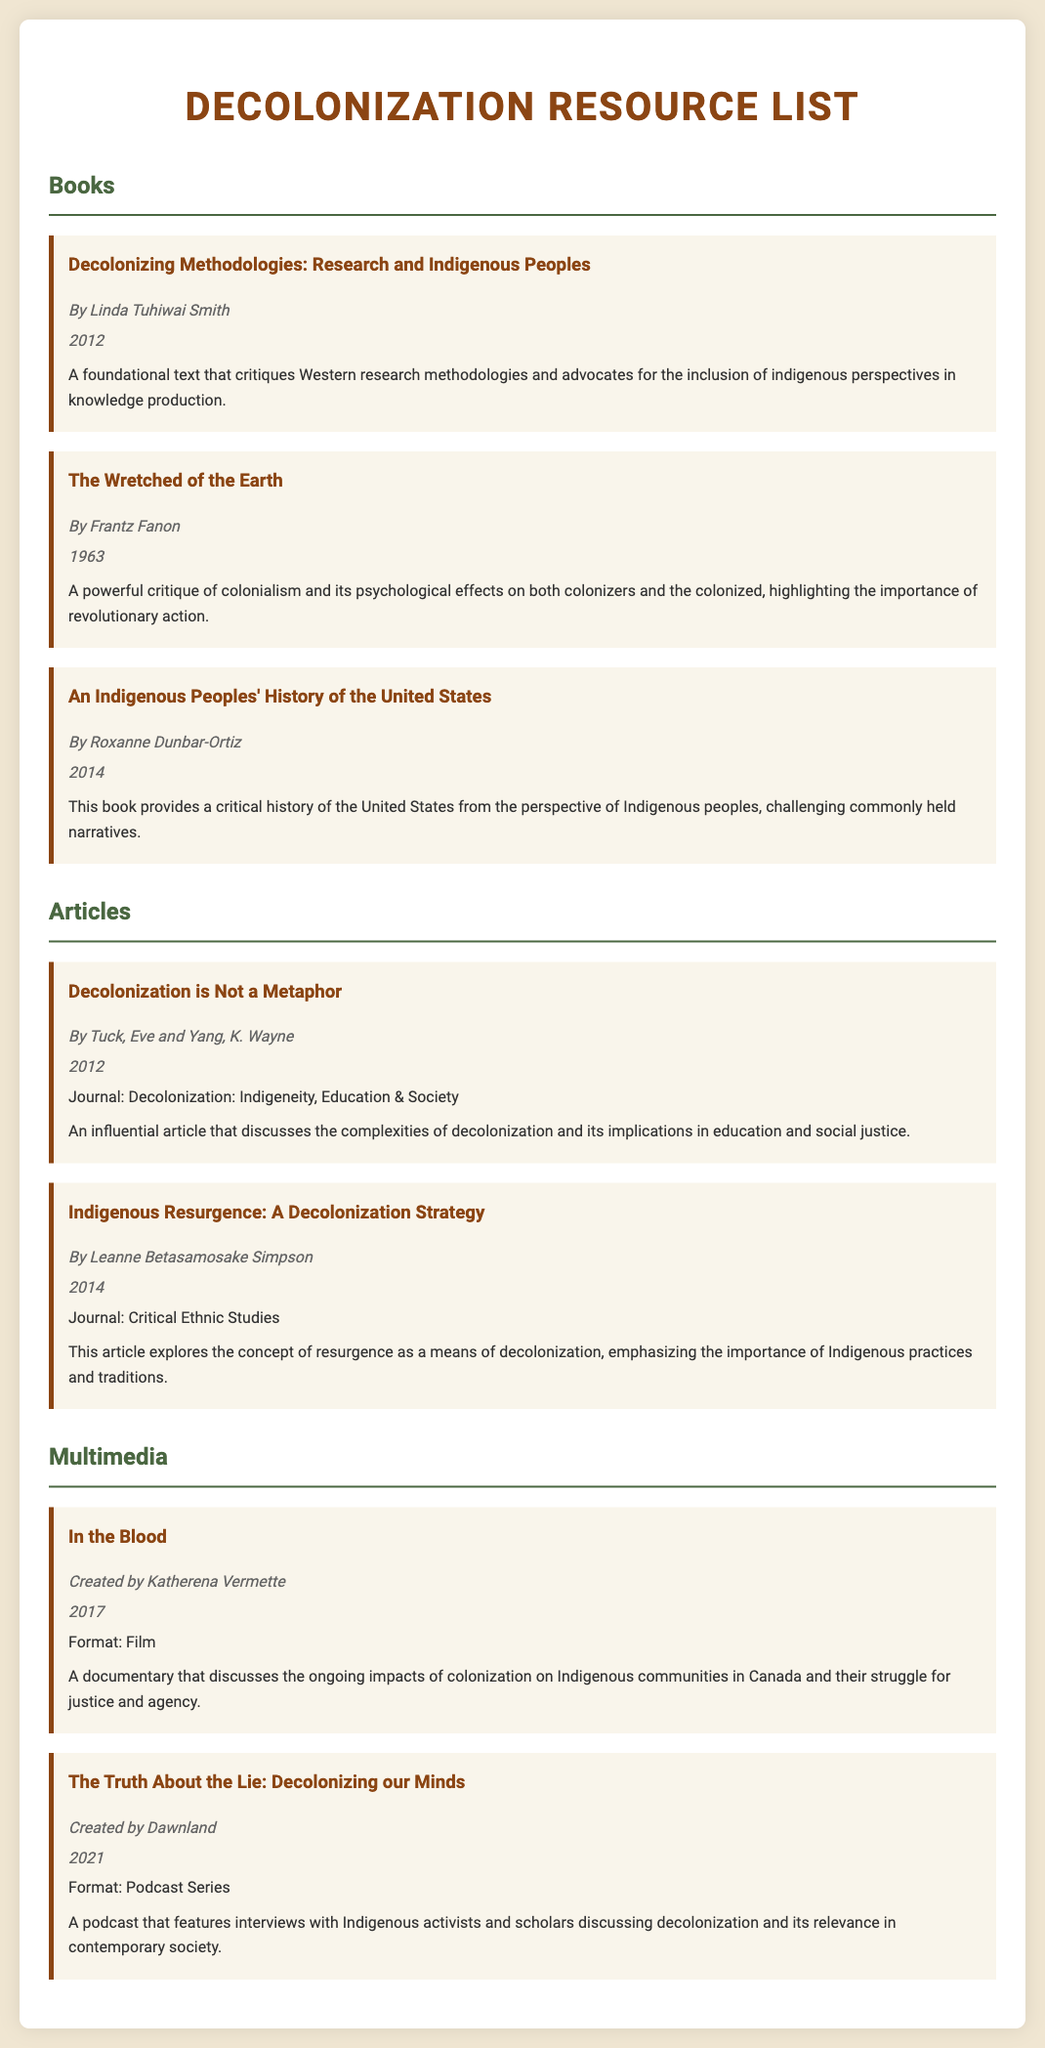What is the title of the first book listed? The title of the first book listed is found in the "Books" section of the document.
Answer: Decolonizing Methodologies: Research and Indigenous Peoples Who is the author of "The Wretched of the Earth"? The author name can be found under the title of the resource in the "Books" section.
Answer: Frantz Fanon What year was "An Indigenous Peoples' History of the United States" published? The publication year is noted alongside the book title in the document.
Answer: 2014 Which journal published the article "Decolonization is Not a Metaphor"? The journal name is provided in the "Articles" section after the article title.
Answer: Decolonization: Indigeneity, Education & Society What is the format of "In the Blood"? The format category is mentioned in the multimedia section with the resource details.
Answer: Film How many authors are listed for the article "Indigenous Resurgence: A Decolonization Strategy"? The number of authors can be determined by counting the names provided under the article title.
Answer: 1 What is the main topic discussed in the podcast series "The Truth About the Lie: Decolonizing our Minds"? The topic is detailed in the description of the multimedia resource in the list.
Answer: Decolonization What theme is central to Linda Tuhiwai Smith's book? The theme can be inferred from the description in the "Books" section regarding the focus of the book.
Answer: Indigenous perspectives in knowledge production What year did the film "In the Blood" get released? The release year is stated alongside the author in the multimedia section of the document.
Answer: 2017 